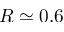Convert formula to latex. <formula><loc_0><loc_0><loc_500><loc_500>R \simeq 0 . 6</formula> 